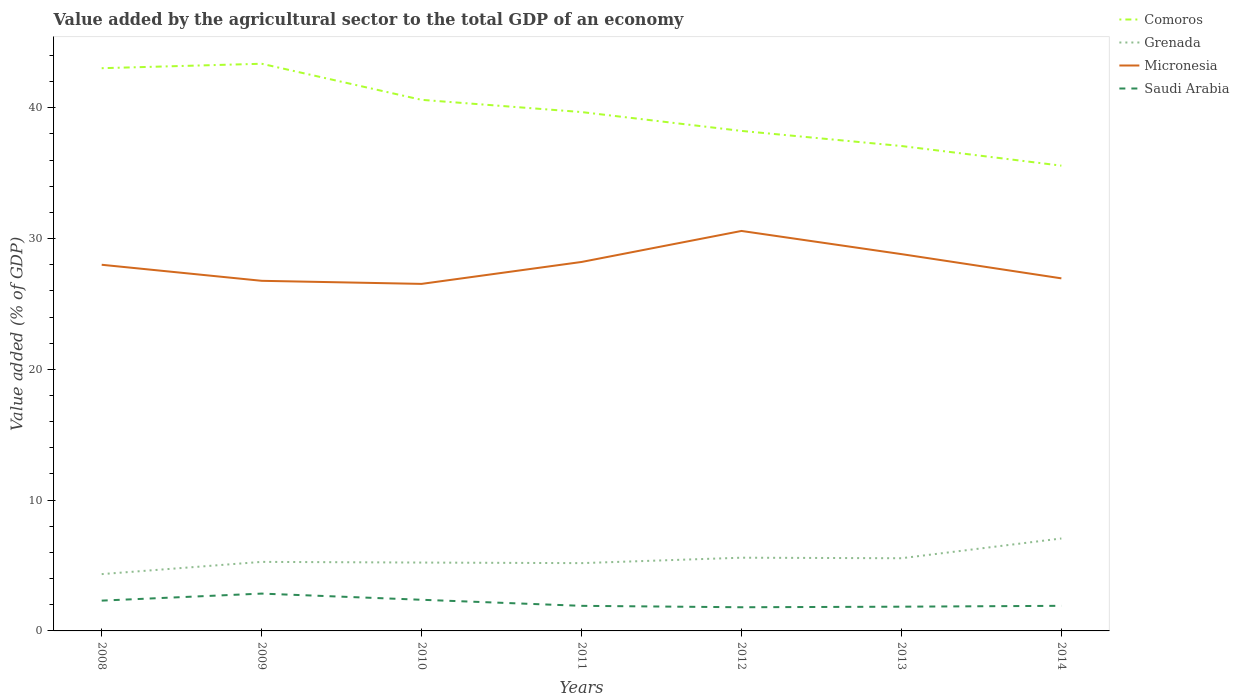How many different coloured lines are there?
Offer a very short reply. 4. Does the line corresponding to Micronesia intersect with the line corresponding to Comoros?
Provide a succinct answer. No. Is the number of lines equal to the number of legend labels?
Your answer should be very brief. Yes. Across all years, what is the maximum value added by the agricultural sector to the total GDP in Saudi Arabia?
Your answer should be very brief. 1.81. What is the total value added by the agricultural sector to the total GDP in Comoros in the graph?
Make the answer very short. 7.45. What is the difference between the highest and the second highest value added by the agricultural sector to the total GDP in Micronesia?
Provide a succinct answer. 4.05. What is the difference between the highest and the lowest value added by the agricultural sector to the total GDP in Comoros?
Your response must be concise. 4. Does the graph contain any zero values?
Give a very brief answer. No. Where does the legend appear in the graph?
Your response must be concise. Top right. How are the legend labels stacked?
Offer a terse response. Vertical. What is the title of the graph?
Provide a succinct answer. Value added by the agricultural sector to the total GDP of an economy. Does "Bermuda" appear as one of the legend labels in the graph?
Your answer should be very brief. No. What is the label or title of the X-axis?
Your answer should be very brief. Years. What is the label or title of the Y-axis?
Make the answer very short. Value added (% of GDP). What is the Value added (% of GDP) in Comoros in 2008?
Offer a very short reply. 43.03. What is the Value added (% of GDP) of Grenada in 2008?
Give a very brief answer. 4.34. What is the Value added (% of GDP) of Micronesia in 2008?
Offer a terse response. 28. What is the Value added (% of GDP) in Saudi Arabia in 2008?
Ensure brevity in your answer.  2.32. What is the Value added (% of GDP) in Comoros in 2009?
Provide a succinct answer. 43.37. What is the Value added (% of GDP) in Grenada in 2009?
Offer a terse response. 5.28. What is the Value added (% of GDP) in Micronesia in 2009?
Your answer should be very brief. 26.77. What is the Value added (% of GDP) of Saudi Arabia in 2009?
Provide a succinct answer. 2.85. What is the Value added (% of GDP) in Comoros in 2010?
Offer a very short reply. 40.61. What is the Value added (% of GDP) of Grenada in 2010?
Offer a terse response. 5.23. What is the Value added (% of GDP) in Micronesia in 2010?
Offer a very short reply. 26.54. What is the Value added (% of GDP) in Saudi Arabia in 2010?
Ensure brevity in your answer.  2.38. What is the Value added (% of GDP) in Comoros in 2011?
Offer a terse response. 39.68. What is the Value added (% of GDP) of Grenada in 2011?
Give a very brief answer. 5.18. What is the Value added (% of GDP) of Micronesia in 2011?
Keep it short and to the point. 28.21. What is the Value added (% of GDP) in Saudi Arabia in 2011?
Your answer should be very brief. 1.92. What is the Value added (% of GDP) of Comoros in 2012?
Your answer should be very brief. 38.23. What is the Value added (% of GDP) of Grenada in 2012?
Provide a short and direct response. 5.6. What is the Value added (% of GDP) in Micronesia in 2012?
Your answer should be very brief. 30.58. What is the Value added (% of GDP) of Saudi Arabia in 2012?
Your response must be concise. 1.81. What is the Value added (% of GDP) of Comoros in 2013?
Provide a short and direct response. 37.08. What is the Value added (% of GDP) in Grenada in 2013?
Your response must be concise. 5.56. What is the Value added (% of GDP) of Micronesia in 2013?
Offer a very short reply. 28.81. What is the Value added (% of GDP) in Saudi Arabia in 2013?
Your answer should be compact. 1.85. What is the Value added (% of GDP) of Comoros in 2014?
Provide a succinct answer. 35.58. What is the Value added (% of GDP) in Grenada in 2014?
Provide a short and direct response. 7.07. What is the Value added (% of GDP) of Micronesia in 2014?
Your answer should be very brief. 26.96. What is the Value added (% of GDP) of Saudi Arabia in 2014?
Give a very brief answer. 1.92. Across all years, what is the maximum Value added (% of GDP) of Comoros?
Your answer should be compact. 43.37. Across all years, what is the maximum Value added (% of GDP) of Grenada?
Your answer should be very brief. 7.07. Across all years, what is the maximum Value added (% of GDP) in Micronesia?
Ensure brevity in your answer.  30.58. Across all years, what is the maximum Value added (% of GDP) of Saudi Arabia?
Make the answer very short. 2.85. Across all years, what is the minimum Value added (% of GDP) in Comoros?
Keep it short and to the point. 35.58. Across all years, what is the minimum Value added (% of GDP) of Grenada?
Offer a terse response. 4.34. Across all years, what is the minimum Value added (% of GDP) in Micronesia?
Ensure brevity in your answer.  26.54. Across all years, what is the minimum Value added (% of GDP) of Saudi Arabia?
Provide a succinct answer. 1.81. What is the total Value added (% of GDP) in Comoros in the graph?
Your answer should be compact. 277.57. What is the total Value added (% of GDP) in Grenada in the graph?
Offer a terse response. 38.26. What is the total Value added (% of GDP) of Micronesia in the graph?
Provide a succinct answer. 195.88. What is the total Value added (% of GDP) in Saudi Arabia in the graph?
Give a very brief answer. 15.05. What is the difference between the Value added (% of GDP) in Comoros in 2008 and that in 2009?
Offer a very short reply. -0.34. What is the difference between the Value added (% of GDP) in Grenada in 2008 and that in 2009?
Your response must be concise. -0.94. What is the difference between the Value added (% of GDP) of Micronesia in 2008 and that in 2009?
Offer a very short reply. 1.23. What is the difference between the Value added (% of GDP) in Saudi Arabia in 2008 and that in 2009?
Provide a short and direct response. -0.54. What is the difference between the Value added (% of GDP) of Comoros in 2008 and that in 2010?
Provide a succinct answer. 2.42. What is the difference between the Value added (% of GDP) of Grenada in 2008 and that in 2010?
Ensure brevity in your answer.  -0.88. What is the difference between the Value added (% of GDP) in Micronesia in 2008 and that in 2010?
Offer a terse response. 1.46. What is the difference between the Value added (% of GDP) in Saudi Arabia in 2008 and that in 2010?
Your answer should be very brief. -0.07. What is the difference between the Value added (% of GDP) in Comoros in 2008 and that in 2011?
Make the answer very short. 3.35. What is the difference between the Value added (% of GDP) in Grenada in 2008 and that in 2011?
Make the answer very short. -0.84. What is the difference between the Value added (% of GDP) in Micronesia in 2008 and that in 2011?
Your response must be concise. -0.21. What is the difference between the Value added (% of GDP) in Saudi Arabia in 2008 and that in 2011?
Your response must be concise. 0.4. What is the difference between the Value added (% of GDP) in Comoros in 2008 and that in 2012?
Provide a short and direct response. 4.8. What is the difference between the Value added (% of GDP) of Grenada in 2008 and that in 2012?
Provide a succinct answer. -1.25. What is the difference between the Value added (% of GDP) in Micronesia in 2008 and that in 2012?
Your response must be concise. -2.59. What is the difference between the Value added (% of GDP) in Saudi Arabia in 2008 and that in 2012?
Your answer should be very brief. 0.51. What is the difference between the Value added (% of GDP) in Comoros in 2008 and that in 2013?
Give a very brief answer. 5.95. What is the difference between the Value added (% of GDP) in Grenada in 2008 and that in 2013?
Offer a terse response. -1.21. What is the difference between the Value added (% of GDP) in Micronesia in 2008 and that in 2013?
Give a very brief answer. -0.81. What is the difference between the Value added (% of GDP) in Saudi Arabia in 2008 and that in 2013?
Your answer should be very brief. 0.46. What is the difference between the Value added (% of GDP) of Comoros in 2008 and that in 2014?
Provide a short and direct response. 7.45. What is the difference between the Value added (% of GDP) in Grenada in 2008 and that in 2014?
Your response must be concise. -2.73. What is the difference between the Value added (% of GDP) of Micronesia in 2008 and that in 2014?
Provide a short and direct response. 1.04. What is the difference between the Value added (% of GDP) of Saudi Arabia in 2008 and that in 2014?
Your response must be concise. 0.4. What is the difference between the Value added (% of GDP) of Comoros in 2009 and that in 2010?
Keep it short and to the point. 2.76. What is the difference between the Value added (% of GDP) in Grenada in 2009 and that in 2010?
Make the answer very short. 0.05. What is the difference between the Value added (% of GDP) in Micronesia in 2009 and that in 2010?
Ensure brevity in your answer.  0.24. What is the difference between the Value added (% of GDP) of Saudi Arabia in 2009 and that in 2010?
Offer a very short reply. 0.47. What is the difference between the Value added (% of GDP) in Comoros in 2009 and that in 2011?
Provide a succinct answer. 3.69. What is the difference between the Value added (% of GDP) of Grenada in 2009 and that in 2011?
Offer a very short reply. 0.1. What is the difference between the Value added (% of GDP) of Micronesia in 2009 and that in 2011?
Provide a short and direct response. -1.44. What is the difference between the Value added (% of GDP) in Saudi Arabia in 2009 and that in 2011?
Ensure brevity in your answer.  0.94. What is the difference between the Value added (% of GDP) in Comoros in 2009 and that in 2012?
Provide a short and direct response. 5.14. What is the difference between the Value added (% of GDP) in Grenada in 2009 and that in 2012?
Offer a terse response. -0.32. What is the difference between the Value added (% of GDP) in Micronesia in 2009 and that in 2012?
Offer a very short reply. -3.81. What is the difference between the Value added (% of GDP) in Saudi Arabia in 2009 and that in 2012?
Offer a terse response. 1.04. What is the difference between the Value added (% of GDP) of Comoros in 2009 and that in 2013?
Offer a terse response. 6.29. What is the difference between the Value added (% of GDP) of Grenada in 2009 and that in 2013?
Offer a terse response. -0.28. What is the difference between the Value added (% of GDP) in Micronesia in 2009 and that in 2013?
Offer a very short reply. -2.04. What is the difference between the Value added (% of GDP) in Comoros in 2009 and that in 2014?
Ensure brevity in your answer.  7.79. What is the difference between the Value added (% of GDP) in Grenada in 2009 and that in 2014?
Your answer should be compact. -1.79. What is the difference between the Value added (% of GDP) of Micronesia in 2009 and that in 2014?
Your answer should be very brief. -0.19. What is the difference between the Value added (% of GDP) in Saudi Arabia in 2009 and that in 2014?
Your response must be concise. 0.93. What is the difference between the Value added (% of GDP) in Comoros in 2010 and that in 2011?
Your answer should be very brief. 0.93. What is the difference between the Value added (% of GDP) of Grenada in 2010 and that in 2011?
Keep it short and to the point. 0.04. What is the difference between the Value added (% of GDP) of Micronesia in 2010 and that in 2011?
Offer a very short reply. -1.68. What is the difference between the Value added (% of GDP) in Saudi Arabia in 2010 and that in 2011?
Ensure brevity in your answer.  0.46. What is the difference between the Value added (% of GDP) of Comoros in 2010 and that in 2012?
Ensure brevity in your answer.  2.38. What is the difference between the Value added (% of GDP) of Grenada in 2010 and that in 2012?
Make the answer very short. -0.37. What is the difference between the Value added (% of GDP) of Micronesia in 2010 and that in 2012?
Your answer should be very brief. -4.05. What is the difference between the Value added (% of GDP) in Saudi Arabia in 2010 and that in 2012?
Ensure brevity in your answer.  0.57. What is the difference between the Value added (% of GDP) of Comoros in 2010 and that in 2013?
Make the answer very short. 3.53. What is the difference between the Value added (% of GDP) of Grenada in 2010 and that in 2013?
Keep it short and to the point. -0.33. What is the difference between the Value added (% of GDP) in Micronesia in 2010 and that in 2013?
Your answer should be compact. -2.28. What is the difference between the Value added (% of GDP) of Saudi Arabia in 2010 and that in 2013?
Keep it short and to the point. 0.53. What is the difference between the Value added (% of GDP) of Comoros in 2010 and that in 2014?
Your answer should be compact. 5.03. What is the difference between the Value added (% of GDP) of Grenada in 2010 and that in 2014?
Ensure brevity in your answer.  -1.84. What is the difference between the Value added (% of GDP) in Micronesia in 2010 and that in 2014?
Your answer should be compact. -0.42. What is the difference between the Value added (% of GDP) in Saudi Arabia in 2010 and that in 2014?
Provide a succinct answer. 0.46. What is the difference between the Value added (% of GDP) of Comoros in 2011 and that in 2012?
Keep it short and to the point. 1.44. What is the difference between the Value added (% of GDP) in Grenada in 2011 and that in 2012?
Your answer should be compact. -0.42. What is the difference between the Value added (% of GDP) in Micronesia in 2011 and that in 2012?
Provide a short and direct response. -2.37. What is the difference between the Value added (% of GDP) in Saudi Arabia in 2011 and that in 2012?
Provide a succinct answer. 0.11. What is the difference between the Value added (% of GDP) in Comoros in 2011 and that in 2013?
Provide a succinct answer. 2.6. What is the difference between the Value added (% of GDP) in Grenada in 2011 and that in 2013?
Ensure brevity in your answer.  -0.37. What is the difference between the Value added (% of GDP) of Micronesia in 2011 and that in 2013?
Offer a terse response. -0.6. What is the difference between the Value added (% of GDP) of Saudi Arabia in 2011 and that in 2013?
Keep it short and to the point. 0.06. What is the difference between the Value added (% of GDP) of Comoros in 2011 and that in 2014?
Your answer should be very brief. 4.1. What is the difference between the Value added (% of GDP) of Grenada in 2011 and that in 2014?
Offer a terse response. -1.89. What is the difference between the Value added (% of GDP) in Micronesia in 2011 and that in 2014?
Provide a short and direct response. 1.25. What is the difference between the Value added (% of GDP) of Saudi Arabia in 2011 and that in 2014?
Your response must be concise. -0. What is the difference between the Value added (% of GDP) in Comoros in 2012 and that in 2013?
Provide a succinct answer. 1.15. What is the difference between the Value added (% of GDP) of Grenada in 2012 and that in 2013?
Offer a terse response. 0.04. What is the difference between the Value added (% of GDP) of Micronesia in 2012 and that in 2013?
Keep it short and to the point. 1.77. What is the difference between the Value added (% of GDP) of Saudi Arabia in 2012 and that in 2013?
Your answer should be compact. -0.04. What is the difference between the Value added (% of GDP) in Comoros in 2012 and that in 2014?
Provide a short and direct response. 2.66. What is the difference between the Value added (% of GDP) in Grenada in 2012 and that in 2014?
Provide a short and direct response. -1.47. What is the difference between the Value added (% of GDP) of Micronesia in 2012 and that in 2014?
Give a very brief answer. 3.62. What is the difference between the Value added (% of GDP) in Saudi Arabia in 2012 and that in 2014?
Your answer should be very brief. -0.11. What is the difference between the Value added (% of GDP) in Comoros in 2013 and that in 2014?
Your answer should be very brief. 1.5. What is the difference between the Value added (% of GDP) in Grenada in 2013 and that in 2014?
Your answer should be compact. -1.51. What is the difference between the Value added (% of GDP) in Micronesia in 2013 and that in 2014?
Keep it short and to the point. 1.85. What is the difference between the Value added (% of GDP) in Saudi Arabia in 2013 and that in 2014?
Offer a terse response. -0.07. What is the difference between the Value added (% of GDP) in Comoros in 2008 and the Value added (% of GDP) in Grenada in 2009?
Give a very brief answer. 37.75. What is the difference between the Value added (% of GDP) in Comoros in 2008 and the Value added (% of GDP) in Micronesia in 2009?
Keep it short and to the point. 16.26. What is the difference between the Value added (% of GDP) of Comoros in 2008 and the Value added (% of GDP) of Saudi Arabia in 2009?
Provide a short and direct response. 40.17. What is the difference between the Value added (% of GDP) in Grenada in 2008 and the Value added (% of GDP) in Micronesia in 2009?
Provide a short and direct response. -22.43. What is the difference between the Value added (% of GDP) of Grenada in 2008 and the Value added (% of GDP) of Saudi Arabia in 2009?
Ensure brevity in your answer.  1.49. What is the difference between the Value added (% of GDP) of Micronesia in 2008 and the Value added (% of GDP) of Saudi Arabia in 2009?
Your response must be concise. 25.14. What is the difference between the Value added (% of GDP) of Comoros in 2008 and the Value added (% of GDP) of Grenada in 2010?
Make the answer very short. 37.8. What is the difference between the Value added (% of GDP) of Comoros in 2008 and the Value added (% of GDP) of Micronesia in 2010?
Offer a terse response. 16.49. What is the difference between the Value added (% of GDP) of Comoros in 2008 and the Value added (% of GDP) of Saudi Arabia in 2010?
Make the answer very short. 40.65. What is the difference between the Value added (% of GDP) in Grenada in 2008 and the Value added (% of GDP) in Micronesia in 2010?
Your response must be concise. -22.19. What is the difference between the Value added (% of GDP) in Grenada in 2008 and the Value added (% of GDP) in Saudi Arabia in 2010?
Your response must be concise. 1.96. What is the difference between the Value added (% of GDP) of Micronesia in 2008 and the Value added (% of GDP) of Saudi Arabia in 2010?
Keep it short and to the point. 25.62. What is the difference between the Value added (% of GDP) of Comoros in 2008 and the Value added (% of GDP) of Grenada in 2011?
Keep it short and to the point. 37.85. What is the difference between the Value added (% of GDP) in Comoros in 2008 and the Value added (% of GDP) in Micronesia in 2011?
Provide a succinct answer. 14.82. What is the difference between the Value added (% of GDP) in Comoros in 2008 and the Value added (% of GDP) in Saudi Arabia in 2011?
Make the answer very short. 41.11. What is the difference between the Value added (% of GDP) of Grenada in 2008 and the Value added (% of GDP) of Micronesia in 2011?
Your answer should be very brief. -23.87. What is the difference between the Value added (% of GDP) in Grenada in 2008 and the Value added (% of GDP) in Saudi Arabia in 2011?
Offer a very short reply. 2.43. What is the difference between the Value added (% of GDP) in Micronesia in 2008 and the Value added (% of GDP) in Saudi Arabia in 2011?
Your answer should be compact. 26.08. What is the difference between the Value added (% of GDP) of Comoros in 2008 and the Value added (% of GDP) of Grenada in 2012?
Give a very brief answer. 37.43. What is the difference between the Value added (% of GDP) in Comoros in 2008 and the Value added (% of GDP) in Micronesia in 2012?
Provide a short and direct response. 12.44. What is the difference between the Value added (% of GDP) in Comoros in 2008 and the Value added (% of GDP) in Saudi Arabia in 2012?
Keep it short and to the point. 41.22. What is the difference between the Value added (% of GDP) in Grenada in 2008 and the Value added (% of GDP) in Micronesia in 2012?
Offer a terse response. -26.24. What is the difference between the Value added (% of GDP) of Grenada in 2008 and the Value added (% of GDP) of Saudi Arabia in 2012?
Your answer should be very brief. 2.53. What is the difference between the Value added (% of GDP) of Micronesia in 2008 and the Value added (% of GDP) of Saudi Arabia in 2012?
Make the answer very short. 26.19. What is the difference between the Value added (% of GDP) in Comoros in 2008 and the Value added (% of GDP) in Grenada in 2013?
Your answer should be compact. 37.47. What is the difference between the Value added (% of GDP) in Comoros in 2008 and the Value added (% of GDP) in Micronesia in 2013?
Your response must be concise. 14.22. What is the difference between the Value added (% of GDP) of Comoros in 2008 and the Value added (% of GDP) of Saudi Arabia in 2013?
Your answer should be compact. 41.18. What is the difference between the Value added (% of GDP) of Grenada in 2008 and the Value added (% of GDP) of Micronesia in 2013?
Give a very brief answer. -24.47. What is the difference between the Value added (% of GDP) in Grenada in 2008 and the Value added (% of GDP) in Saudi Arabia in 2013?
Give a very brief answer. 2.49. What is the difference between the Value added (% of GDP) in Micronesia in 2008 and the Value added (% of GDP) in Saudi Arabia in 2013?
Give a very brief answer. 26.14. What is the difference between the Value added (% of GDP) in Comoros in 2008 and the Value added (% of GDP) in Grenada in 2014?
Ensure brevity in your answer.  35.96. What is the difference between the Value added (% of GDP) in Comoros in 2008 and the Value added (% of GDP) in Micronesia in 2014?
Your response must be concise. 16.07. What is the difference between the Value added (% of GDP) of Comoros in 2008 and the Value added (% of GDP) of Saudi Arabia in 2014?
Your answer should be very brief. 41.11. What is the difference between the Value added (% of GDP) in Grenada in 2008 and the Value added (% of GDP) in Micronesia in 2014?
Your answer should be very brief. -22.62. What is the difference between the Value added (% of GDP) of Grenada in 2008 and the Value added (% of GDP) of Saudi Arabia in 2014?
Provide a succinct answer. 2.42. What is the difference between the Value added (% of GDP) of Micronesia in 2008 and the Value added (% of GDP) of Saudi Arabia in 2014?
Offer a very short reply. 26.08. What is the difference between the Value added (% of GDP) of Comoros in 2009 and the Value added (% of GDP) of Grenada in 2010?
Provide a succinct answer. 38.14. What is the difference between the Value added (% of GDP) in Comoros in 2009 and the Value added (% of GDP) in Micronesia in 2010?
Your answer should be very brief. 16.83. What is the difference between the Value added (% of GDP) in Comoros in 2009 and the Value added (% of GDP) in Saudi Arabia in 2010?
Your response must be concise. 40.99. What is the difference between the Value added (% of GDP) of Grenada in 2009 and the Value added (% of GDP) of Micronesia in 2010?
Ensure brevity in your answer.  -21.26. What is the difference between the Value added (% of GDP) of Grenada in 2009 and the Value added (% of GDP) of Saudi Arabia in 2010?
Your answer should be compact. 2.9. What is the difference between the Value added (% of GDP) in Micronesia in 2009 and the Value added (% of GDP) in Saudi Arabia in 2010?
Offer a very short reply. 24.39. What is the difference between the Value added (% of GDP) in Comoros in 2009 and the Value added (% of GDP) in Grenada in 2011?
Give a very brief answer. 38.19. What is the difference between the Value added (% of GDP) of Comoros in 2009 and the Value added (% of GDP) of Micronesia in 2011?
Offer a very short reply. 15.16. What is the difference between the Value added (% of GDP) in Comoros in 2009 and the Value added (% of GDP) in Saudi Arabia in 2011?
Give a very brief answer. 41.45. What is the difference between the Value added (% of GDP) of Grenada in 2009 and the Value added (% of GDP) of Micronesia in 2011?
Give a very brief answer. -22.93. What is the difference between the Value added (% of GDP) of Grenada in 2009 and the Value added (% of GDP) of Saudi Arabia in 2011?
Provide a short and direct response. 3.36. What is the difference between the Value added (% of GDP) in Micronesia in 2009 and the Value added (% of GDP) in Saudi Arabia in 2011?
Ensure brevity in your answer.  24.85. What is the difference between the Value added (% of GDP) in Comoros in 2009 and the Value added (% of GDP) in Grenada in 2012?
Your answer should be very brief. 37.77. What is the difference between the Value added (% of GDP) of Comoros in 2009 and the Value added (% of GDP) of Micronesia in 2012?
Your answer should be compact. 12.78. What is the difference between the Value added (% of GDP) in Comoros in 2009 and the Value added (% of GDP) in Saudi Arabia in 2012?
Your answer should be compact. 41.56. What is the difference between the Value added (% of GDP) in Grenada in 2009 and the Value added (% of GDP) in Micronesia in 2012?
Offer a terse response. -25.31. What is the difference between the Value added (% of GDP) of Grenada in 2009 and the Value added (% of GDP) of Saudi Arabia in 2012?
Make the answer very short. 3.47. What is the difference between the Value added (% of GDP) of Micronesia in 2009 and the Value added (% of GDP) of Saudi Arabia in 2012?
Provide a succinct answer. 24.96. What is the difference between the Value added (% of GDP) in Comoros in 2009 and the Value added (% of GDP) in Grenada in 2013?
Keep it short and to the point. 37.81. What is the difference between the Value added (% of GDP) of Comoros in 2009 and the Value added (% of GDP) of Micronesia in 2013?
Your answer should be very brief. 14.56. What is the difference between the Value added (% of GDP) of Comoros in 2009 and the Value added (% of GDP) of Saudi Arabia in 2013?
Your answer should be very brief. 41.52. What is the difference between the Value added (% of GDP) in Grenada in 2009 and the Value added (% of GDP) in Micronesia in 2013?
Ensure brevity in your answer.  -23.53. What is the difference between the Value added (% of GDP) of Grenada in 2009 and the Value added (% of GDP) of Saudi Arabia in 2013?
Provide a short and direct response. 3.43. What is the difference between the Value added (% of GDP) in Micronesia in 2009 and the Value added (% of GDP) in Saudi Arabia in 2013?
Provide a short and direct response. 24.92. What is the difference between the Value added (% of GDP) of Comoros in 2009 and the Value added (% of GDP) of Grenada in 2014?
Your answer should be very brief. 36.3. What is the difference between the Value added (% of GDP) of Comoros in 2009 and the Value added (% of GDP) of Micronesia in 2014?
Provide a succinct answer. 16.41. What is the difference between the Value added (% of GDP) in Comoros in 2009 and the Value added (% of GDP) in Saudi Arabia in 2014?
Provide a short and direct response. 41.45. What is the difference between the Value added (% of GDP) of Grenada in 2009 and the Value added (% of GDP) of Micronesia in 2014?
Your answer should be compact. -21.68. What is the difference between the Value added (% of GDP) of Grenada in 2009 and the Value added (% of GDP) of Saudi Arabia in 2014?
Your answer should be very brief. 3.36. What is the difference between the Value added (% of GDP) in Micronesia in 2009 and the Value added (% of GDP) in Saudi Arabia in 2014?
Make the answer very short. 24.85. What is the difference between the Value added (% of GDP) of Comoros in 2010 and the Value added (% of GDP) of Grenada in 2011?
Offer a very short reply. 35.43. What is the difference between the Value added (% of GDP) in Comoros in 2010 and the Value added (% of GDP) in Micronesia in 2011?
Provide a short and direct response. 12.4. What is the difference between the Value added (% of GDP) of Comoros in 2010 and the Value added (% of GDP) of Saudi Arabia in 2011?
Give a very brief answer. 38.69. What is the difference between the Value added (% of GDP) in Grenada in 2010 and the Value added (% of GDP) in Micronesia in 2011?
Provide a succinct answer. -22.98. What is the difference between the Value added (% of GDP) of Grenada in 2010 and the Value added (% of GDP) of Saudi Arabia in 2011?
Your response must be concise. 3.31. What is the difference between the Value added (% of GDP) of Micronesia in 2010 and the Value added (% of GDP) of Saudi Arabia in 2011?
Your answer should be compact. 24.62. What is the difference between the Value added (% of GDP) of Comoros in 2010 and the Value added (% of GDP) of Grenada in 2012?
Your answer should be compact. 35.01. What is the difference between the Value added (% of GDP) in Comoros in 2010 and the Value added (% of GDP) in Micronesia in 2012?
Offer a terse response. 10.03. What is the difference between the Value added (% of GDP) of Comoros in 2010 and the Value added (% of GDP) of Saudi Arabia in 2012?
Offer a very short reply. 38.8. What is the difference between the Value added (% of GDP) in Grenada in 2010 and the Value added (% of GDP) in Micronesia in 2012?
Offer a terse response. -25.36. What is the difference between the Value added (% of GDP) of Grenada in 2010 and the Value added (% of GDP) of Saudi Arabia in 2012?
Provide a succinct answer. 3.42. What is the difference between the Value added (% of GDP) in Micronesia in 2010 and the Value added (% of GDP) in Saudi Arabia in 2012?
Provide a succinct answer. 24.73. What is the difference between the Value added (% of GDP) of Comoros in 2010 and the Value added (% of GDP) of Grenada in 2013?
Make the answer very short. 35.05. What is the difference between the Value added (% of GDP) of Comoros in 2010 and the Value added (% of GDP) of Micronesia in 2013?
Give a very brief answer. 11.8. What is the difference between the Value added (% of GDP) in Comoros in 2010 and the Value added (% of GDP) in Saudi Arabia in 2013?
Keep it short and to the point. 38.76. What is the difference between the Value added (% of GDP) of Grenada in 2010 and the Value added (% of GDP) of Micronesia in 2013?
Your answer should be very brief. -23.59. What is the difference between the Value added (% of GDP) of Grenada in 2010 and the Value added (% of GDP) of Saudi Arabia in 2013?
Your answer should be very brief. 3.37. What is the difference between the Value added (% of GDP) in Micronesia in 2010 and the Value added (% of GDP) in Saudi Arabia in 2013?
Your answer should be compact. 24.68. What is the difference between the Value added (% of GDP) in Comoros in 2010 and the Value added (% of GDP) in Grenada in 2014?
Your answer should be very brief. 33.54. What is the difference between the Value added (% of GDP) in Comoros in 2010 and the Value added (% of GDP) in Micronesia in 2014?
Keep it short and to the point. 13.65. What is the difference between the Value added (% of GDP) in Comoros in 2010 and the Value added (% of GDP) in Saudi Arabia in 2014?
Make the answer very short. 38.69. What is the difference between the Value added (% of GDP) of Grenada in 2010 and the Value added (% of GDP) of Micronesia in 2014?
Provide a short and direct response. -21.73. What is the difference between the Value added (% of GDP) in Grenada in 2010 and the Value added (% of GDP) in Saudi Arabia in 2014?
Give a very brief answer. 3.31. What is the difference between the Value added (% of GDP) of Micronesia in 2010 and the Value added (% of GDP) of Saudi Arabia in 2014?
Provide a short and direct response. 24.62. What is the difference between the Value added (% of GDP) of Comoros in 2011 and the Value added (% of GDP) of Grenada in 2012?
Provide a succinct answer. 34.08. What is the difference between the Value added (% of GDP) of Comoros in 2011 and the Value added (% of GDP) of Micronesia in 2012?
Keep it short and to the point. 9.09. What is the difference between the Value added (% of GDP) of Comoros in 2011 and the Value added (% of GDP) of Saudi Arabia in 2012?
Your answer should be very brief. 37.87. What is the difference between the Value added (% of GDP) in Grenada in 2011 and the Value added (% of GDP) in Micronesia in 2012?
Offer a very short reply. -25.4. What is the difference between the Value added (% of GDP) of Grenada in 2011 and the Value added (% of GDP) of Saudi Arabia in 2012?
Provide a succinct answer. 3.37. What is the difference between the Value added (% of GDP) in Micronesia in 2011 and the Value added (% of GDP) in Saudi Arabia in 2012?
Your response must be concise. 26.4. What is the difference between the Value added (% of GDP) of Comoros in 2011 and the Value added (% of GDP) of Grenada in 2013?
Make the answer very short. 34.12. What is the difference between the Value added (% of GDP) of Comoros in 2011 and the Value added (% of GDP) of Micronesia in 2013?
Offer a very short reply. 10.86. What is the difference between the Value added (% of GDP) of Comoros in 2011 and the Value added (% of GDP) of Saudi Arabia in 2013?
Give a very brief answer. 37.82. What is the difference between the Value added (% of GDP) of Grenada in 2011 and the Value added (% of GDP) of Micronesia in 2013?
Provide a short and direct response. -23.63. What is the difference between the Value added (% of GDP) of Grenada in 2011 and the Value added (% of GDP) of Saudi Arabia in 2013?
Make the answer very short. 3.33. What is the difference between the Value added (% of GDP) of Micronesia in 2011 and the Value added (% of GDP) of Saudi Arabia in 2013?
Provide a short and direct response. 26.36. What is the difference between the Value added (% of GDP) of Comoros in 2011 and the Value added (% of GDP) of Grenada in 2014?
Provide a short and direct response. 32.61. What is the difference between the Value added (% of GDP) of Comoros in 2011 and the Value added (% of GDP) of Micronesia in 2014?
Offer a terse response. 12.72. What is the difference between the Value added (% of GDP) in Comoros in 2011 and the Value added (% of GDP) in Saudi Arabia in 2014?
Your answer should be compact. 37.76. What is the difference between the Value added (% of GDP) of Grenada in 2011 and the Value added (% of GDP) of Micronesia in 2014?
Provide a succinct answer. -21.78. What is the difference between the Value added (% of GDP) of Grenada in 2011 and the Value added (% of GDP) of Saudi Arabia in 2014?
Provide a succinct answer. 3.26. What is the difference between the Value added (% of GDP) in Micronesia in 2011 and the Value added (% of GDP) in Saudi Arabia in 2014?
Keep it short and to the point. 26.29. What is the difference between the Value added (% of GDP) in Comoros in 2012 and the Value added (% of GDP) in Grenada in 2013?
Offer a terse response. 32.68. What is the difference between the Value added (% of GDP) in Comoros in 2012 and the Value added (% of GDP) in Micronesia in 2013?
Offer a very short reply. 9.42. What is the difference between the Value added (% of GDP) in Comoros in 2012 and the Value added (% of GDP) in Saudi Arabia in 2013?
Ensure brevity in your answer.  36.38. What is the difference between the Value added (% of GDP) in Grenada in 2012 and the Value added (% of GDP) in Micronesia in 2013?
Provide a short and direct response. -23.21. What is the difference between the Value added (% of GDP) in Grenada in 2012 and the Value added (% of GDP) in Saudi Arabia in 2013?
Provide a short and direct response. 3.75. What is the difference between the Value added (% of GDP) of Micronesia in 2012 and the Value added (% of GDP) of Saudi Arabia in 2013?
Ensure brevity in your answer.  28.73. What is the difference between the Value added (% of GDP) in Comoros in 2012 and the Value added (% of GDP) in Grenada in 2014?
Provide a short and direct response. 31.16. What is the difference between the Value added (% of GDP) of Comoros in 2012 and the Value added (% of GDP) of Micronesia in 2014?
Your response must be concise. 11.27. What is the difference between the Value added (% of GDP) in Comoros in 2012 and the Value added (% of GDP) in Saudi Arabia in 2014?
Your response must be concise. 36.31. What is the difference between the Value added (% of GDP) in Grenada in 2012 and the Value added (% of GDP) in Micronesia in 2014?
Offer a very short reply. -21.36. What is the difference between the Value added (% of GDP) of Grenada in 2012 and the Value added (% of GDP) of Saudi Arabia in 2014?
Offer a terse response. 3.68. What is the difference between the Value added (% of GDP) in Micronesia in 2012 and the Value added (% of GDP) in Saudi Arabia in 2014?
Provide a short and direct response. 28.66. What is the difference between the Value added (% of GDP) of Comoros in 2013 and the Value added (% of GDP) of Grenada in 2014?
Ensure brevity in your answer.  30.01. What is the difference between the Value added (% of GDP) of Comoros in 2013 and the Value added (% of GDP) of Micronesia in 2014?
Give a very brief answer. 10.12. What is the difference between the Value added (% of GDP) in Comoros in 2013 and the Value added (% of GDP) in Saudi Arabia in 2014?
Your response must be concise. 35.16. What is the difference between the Value added (% of GDP) in Grenada in 2013 and the Value added (% of GDP) in Micronesia in 2014?
Make the answer very short. -21.4. What is the difference between the Value added (% of GDP) in Grenada in 2013 and the Value added (% of GDP) in Saudi Arabia in 2014?
Your response must be concise. 3.64. What is the difference between the Value added (% of GDP) in Micronesia in 2013 and the Value added (% of GDP) in Saudi Arabia in 2014?
Give a very brief answer. 26.89. What is the average Value added (% of GDP) of Comoros per year?
Give a very brief answer. 39.65. What is the average Value added (% of GDP) of Grenada per year?
Keep it short and to the point. 5.47. What is the average Value added (% of GDP) in Micronesia per year?
Make the answer very short. 27.98. What is the average Value added (% of GDP) of Saudi Arabia per year?
Your answer should be very brief. 2.15. In the year 2008, what is the difference between the Value added (% of GDP) in Comoros and Value added (% of GDP) in Grenada?
Offer a very short reply. 38.69. In the year 2008, what is the difference between the Value added (% of GDP) in Comoros and Value added (% of GDP) in Micronesia?
Offer a terse response. 15.03. In the year 2008, what is the difference between the Value added (% of GDP) in Comoros and Value added (% of GDP) in Saudi Arabia?
Keep it short and to the point. 40.71. In the year 2008, what is the difference between the Value added (% of GDP) of Grenada and Value added (% of GDP) of Micronesia?
Provide a succinct answer. -23.65. In the year 2008, what is the difference between the Value added (% of GDP) in Grenada and Value added (% of GDP) in Saudi Arabia?
Provide a succinct answer. 2.03. In the year 2008, what is the difference between the Value added (% of GDP) of Micronesia and Value added (% of GDP) of Saudi Arabia?
Your answer should be compact. 25.68. In the year 2009, what is the difference between the Value added (% of GDP) in Comoros and Value added (% of GDP) in Grenada?
Give a very brief answer. 38.09. In the year 2009, what is the difference between the Value added (% of GDP) of Comoros and Value added (% of GDP) of Micronesia?
Provide a short and direct response. 16.6. In the year 2009, what is the difference between the Value added (% of GDP) of Comoros and Value added (% of GDP) of Saudi Arabia?
Give a very brief answer. 40.52. In the year 2009, what is the difference between the Value added (% of GDP) in Grenada and Value added (% of GDP) in Micronesia?
Provide a succinct answer. -21.49. In the year 2009, what is the difference between the Value added (% of GDP) in Grenada and Value added (% of GDP) in Saudi Arabia?
Make the answer very short. 2.43. In the year 2009, what is the difference between the Value added (% of GDP) of Micronesia and Value added (% of GDP) of Saudi Arabia?
Offer a very short reply. 23.92. In the year 2010, what is the difference between the Value added (% of GDP) of Comoros and Value added (% of GDP) of Grenada?
Provide a succinct answer. 35.38. In the year 2010, what is the difference between the Value added (% of GDP) in Comoros and Value added (% of GDP) in Micronesia?
Your answer should be very brief. 14.07. In the year 2010, what is the difference between the Value added (% of GDP) of Comoros and Value added (% of GDP) of Saudi Arabia?
Ensure brevity in your answer.  38.23. In the year 2010, what is the difference between the Value added (% of GDP) of Grenada and Value added (% of GDP) of Micronesia?
Ensure brevity in your answer.  -21.31. In the year 2010, what is the difference between the Value added (% of GDP) in Grenada and Value added (% of GDP) in Saudi Arabia?
Your response must be concise. 2.85. In the year 2010, what is the difference between the Value added (% of GDP) of Micronesia and Value added (% of GDP) of Saudi Arabia?
Give a very brief answer. 24.15. In the year 2011, what is the difference between the Value added (% of GDP) in Comoros and Value added (% of GDP) in Grenada?
Provide a short and direct response. 34.49. In the year 2011, what is the difference between the Value added (% of GDP) of Comoros and Value added (% of GDP) of Micronesia?
Offer a very short reply. 11.46. In the year 2011, what is the difference between the Value added (% of GDP) of Comoros and Value added (% of GDP) of Saudi Arabia?
Provide a short and direct response. 37.76. In the year 2011, what is the difference between the Value added (% of GDP) of Grenada and Value added (% of GDP) of Micronesia?
Keep it short and to the point. -23.03. In the year 2011, what is the difference between the Value added (% of GDP) of Grenada and Value added (% of GDP) of Saudi Arabia?
Offer a very short reply. 3.27. In the year 2011, what is the difference between the Value added (% of GDP) in Micronesia and Value added (% of GDP) in Saudi Arabia?
Ensure brevity in your answer.  26.29. In the year 2012, what is the difference between the Value added (% of GDP) of Comoros and Value added (% of GDP) of Grenada?
Give a very brief answer. 32.63. In the year 2012, what is the difference between the Value added (% of GDP) of Comoros and Value added (% of GDP) of Micronesia?
Offer a terse response. 7.65. In the year 2012, what is the difference between the Value added (% of GDP) of Comoros and Value added (% of GDP) of Saudi Arabia?
Your answer should be very brief. 36.42. In the year 2012, what is the difference between the Value added (% of GDP) of Grenada and Value added (% of GDP) of Micronesia?
Your answer should be very brief. -24.99. In the year 2012, what is the difference between the Value added (% of GDP) of Grenada and Value added (% of GDP) of Saudi Arabia?
Offer a very short reply. 3.79. In the year 2012, what is the difference between the Value added (% of GDP) in Micronesia and Value added (% of GDP) in Saudi Arabia?
Offer a terse response. 28.77. In the year 2013, what is the difference between the Value added (% of GDP) of Comoros and Value added (% of GDP) of Grenada?
Your answer should be very brief. 31.52. In the year 2013, what is the difference between the Value added (% of GDP) in Comoros and Value added (% of GDP) in Micronesia?
Ensure brevity in your answer.  8.27. In the year 2013, what is the difference between the Value added (% of GDP) of Comoros and Value added (% of GDP) of Saudi Arabia?
Offer a very short reply. 35.23. In the year 2013, what is the difference between the Value added (% of GDP) in Grenada and Value added (% of GDP) in Micronesia?
Offer a very short reply. -23.26. In the year 2013, what is the difference between the Value added (% of GDP) of Grenada and Value added (% of GDP) of Saudi Arabia?
Your answer should be very brief. 3.7. In the year 2013, what is the difference between the Value added (% of GDP) in Micronesia and Value added (% of GDP) in Saudi Arabia?
Your answer should be very brief. 26.96. In the year 2014, what is the difference between the Value added (% of GDP) of Comoros and Value added (% of GDP) of Grenada?
Provide a short and direct response. 28.51. In the year 2014, what is the difference between the Value added (% of GDP) of Comoros and Value added (% of GDP) of Micronesia?
Give a very brief answer. 8.62. In the year 2014, what is the difference between the Value added (% of GDP) in Comoros and Value added (% of GDP) in Saudi Arabia?
Keep it short and to the point. 33.66. In the year 2014, what is the difference between the Value added (% of GDP) in Grenada and Value added (% of GDP) in Micronesia?
Your answer should be very brief. -19.89. In the year 2014, what is the difference between the Value added (% of GDP) in Grenada and Value added (% of GDP) in Saudi Arabia?
Your response must be concise. 5.15. In the year 2014, what is the difference between the Value added (% of GDP) in Micronesia and Value added (% of GDP) in Saudi Arabia?
Offer a very short reply. 25.04. What is the ratio of the Value added (% of GDP) of Grenada in 2008 to that in 2009?
Keep it short and to the point. 0.82. What is the ratio of the Value added (% of GDP) of Micronesia in 2008 to that in 2009?
Make the answer very short. 1.05. What is the ratio of the Value added (% of GDP) in Saudi Arabia in 2008 to that in 2009?
Give a very brief answer. 0.81. What is the ratio of the Value added (% of GDP) of Comoros in 2008 to that in 2010?
Provide a short and direct response. 1.06. What is the ratio of the Value added (% of GDP) in Grenada in 2008 to that in 2010?
Offer a terse response. 0.83. What is the ratio of the Value added (% of GDP) in Micronesia in 2008 to that in 2010?
Keep it short and to the point. 1.06. What is the ratio of the Value added (% of GDP) in Saudi Arabia in 2008 to that in 2010?
Your response must be concise. 0.97. What is the ratio of the Value added (% of GDP) of Comoros in 2008 to that in 2011?
Your answer should be compact. 1.08. What is the ratio of the Value added (% of GDP) of Grenada in 2008 to that in 2011?
Your answer should be very brief. 0.84. What is the ratio of the Value added (% of GDP) in Saudi Arabia in 2008 to that in 2011?
Provide a succinct answer. 1.21. What is the ratio of the Value added (% of GDP) in Comoros in 2008 to that in 2012?
Your answer should be very brief. 1.13. What is the ratio of the Value added (% of GDP) of Grenada in 2008 to that in 2012?
Make the answer very short. 0.78. What is the ratio of the Value added (% of GDP) in Micronesia in 2008 to that in 2012?
Your response must be concise. 0.92. What is the ratio of the Value added (% of GDP) of Saudi Arabia in 2008 to that in 2012?
Provide a succinct answer. 1.28. What is the ratio of the Value added (% of GDP) in Comoros in 2008 to that in 2013?
Keep it short and to the point. 1.16. What is the ratio of the Value added (% of GDP) in Grenada in 2008 to that in 2013?
Your answer should be compact. 0.78. What is the ratio of the Value added (% of GDP) in Micronesia in 2008 to that in 2013?
Offer a terse response. 0.97. What is the ratio of the Value added (% of GDP) of Comoros in 2008 to that in 2014?
Give a very brief answer. 1.21. What is the ratio of the Value added (% of GDP) of Grenada in 2008 to that in 2014?
Offer a very short reply. 0.61. What is the ratio of the Value added (% of GDP) of Saudi Arabia in 2008 to that in 2014?
Ensure brevity in your answer.  1.21. What is the ratio of the Value added (% of GDP) in Comoros in 2009 to that in 2010?
Provide a short and direct response. 1.07. What is the ratio of the Value added (% of GDP) of Grenada in 2009 to that in 2010?
Provide a succinct answer. 1.01. What is the ratio of the Value added (% of GDP) of Micronesia in 2009 to that in 2010?
Give a very brief answer. 1.01. What is the ratio of the Value added (% of GDP) in Saudi Arabia in 2009 to that in 2010?
Keep it short and to the point. 1.2. What is the ratio of the Value added (% of GDP) of Comoros in 2009 to that in 2011?
Offer a very short reply. 1.09. What is the ratio of the Value added (% of GDP) in Grenada in 2009 to that in 2011?
Your response must be concise. 1.02. What is the ratio of the Value added (% of GDP) of Micronesia in 2009 to that in 2011?
Your answer should be very brief. 0.95. What is the ratio of the Value added (% of GDP) in Saudi Arabia in 2009 to that in 2011?
Ensure brevity in your answer.  1.49. What is the ratio of the Value added (% of GDP) of Comoros in 2009 to that in 2012?
Your response must be concise. 1.13. What is the ratio of the Value added (% of GDP) of Grenada in 2009 to that in 2012?
Make the answer very short. 0.94. What is the ratio of the Value added (% of GDP) of Micronesia in 2009 to that in 2012?
Offer a terse response. 0.88. What is the ratio of the Value added (% of GDP) of Saudi Arabia in 2009 to that in 2012?
Provide a succinct answer. 1.58. What is the ratio of the Value added (% of GDP) in Comoros in 2009 to that in 2013?
Your answer should be compact. 1.17. What is the ratio of the Value added (% of GDP) in Grenada in 2009 to that in 2013?
Make the answer very short. 0.95. What is the ratio of the Value added (% of GDP) in Micronesia in 2009 to that in 2013?
Provide a succinct answer. 0.93. What is the ratio of the Value added (% of GDP) in Saudi Arabia in 2009 to that in 2013?
Make the answer very short. 1.54. What is the ratio of the Value added (% of GDP) in Comoros in 2009 to that in 2014?
Offer a terse response. 1.22. What is the ratio of the Value added (% of GDP) in Grenada in 2009 to that in 2014?
Ensure brevity in your answer.  0.75. What is the ratio of the Value added (% of GDP) of Saudi Arabia in 2009 to that in 2014?
Your answer should be very brief. 1.49. What is the ratio of the Value added (% of GDP) in Comoros in 2010 to that in 2011?
Offer a terse response. 1.02. What is the ratio of the Value added (% of GDP) in Grenada in 2010 to that in 2011?
Make the answer very short. 1.01. What is the ratio of the Value added (% of GDP) in Micronesia in 2010 to that in 2011?
Keep it short and to the point. 0.94. What is the ratio of the Value added (% of GDP) of Saudi Arabia in 2010 to that in 2011?
Provide a succinct answer. 1.24. What is the ratio of the Value added (% of GDP) of Comoros in 2010 to that in 2012?
Provide a short and direct response. 1.06. What is the ratio of the Value added (% of GDP) of Grenada in 2010 to that in 2012?
Offer a very short reply. 0.93. What is the ratio of the Value added (% of GDP) of Micronesia in 2010 to that in 2012?
Offer a terse response. 0.87. What is the ratio of the Value added (% of GDP) in Saudi Arabia in 2010 to that in 2012?
Ensure brevity in your answer.  1.32. What is the ratio of the Value added (% of GDP) in Comoros in 2010 to that in 2013?
Ensure brevity in your answer.  1.1. What is the ratio of the Value added (% of GDP) of Grenada in 2010 to that in 2013?
Offer a terse response. 0.94. What is the ratio of the Value added (% of GDP) of Micronesia in 2010 to that in 2013?
Your answer should be very brief. 0.92. What is the ratio of the Value added (% of GDP) in Saudi Arabia in 2010 to that in 2013?
Offer a terse response. 1.29. What is the ratio of the Value added (% of GDP) in Comoros in 2010 to that in 2014?
Offer a very short reply. 1.14. What is the ratio of the Value added (% of GDP) in Grenada in 2010 to that in 2014?
Ensure brevity in your answer.  0.74. What is the ratio of the Value added (% of GDP) in Micronesia in 2010 to that in 2014?
Your answer should be compact. 0.98. What is the ratio of the Value added (% of GDP) of Saudi Arabia in 2010 to that in 2014?
Give a very brief answer. 1.24. What is the ratio of the Value added (% of GDP) of Comoros in 2011 to that in 2012?
Provide a succinct answer. 1.04. What is the ratio of the Value added (% of GDP) in Grenada in 2011 to that in 2012?
Your answer should be compact. 0.93. What is the ratio of the Value added (% of GDP) of Micronesia in 2011 to that in 2012?
Offer a very short reply. 0.92. What is the ratio of the Value added (% of GDP) in Saudi Arabia in 2011 to that in 2012?
Your answer should be very brief. 1.06. What is the ratio of the Value added (% of GDP) of Comoros in 2011 to that in 2013?
Offer a terse response. 1.07. What is the ratio of the Value added (% of GDP) of Grenada in 2011 to that in 2013?
Your answer should be compact. 0.93. What is the ratio of the Value added (% of GDP) of Micronesia in 2011 to that in 2013?
Give a very brief answer. 0.98. What is the ratio of the Value added (% of GDP) in Saudi Arabia in 2011 to that in 2013?
Your response must be concise. 1.03. What is the ratio of the Value added (% of GDP) of Comoros in 2011 to that in 2014?
Your answer should be very brief. 1.12. What is the ratio of the Value added (% of GDP) of Grenada in 2011 to that in 2014?
Provide a succinct answer. 0.73. What is the ratio of the Value added (% of GDP) of Micronesia in 2011 to that in 2014?
Your answer should be very brief. 1.05. What is the ratio of the Value added (% of GDP) of Saudi Arabia in 2011 to that in 2014?
Your answer should be compact. 1. What is the ratio of the Value added (% of GDP) in Comoros in 2012 to that in 2013?
Your response must be concise. 1.03. What is the ratio of the Value added (% of GDP) of Grenada in 2012 to that in 2013?
Your answer should be compact. 1.01. What is the ratio of the Value added (% of GDP) of Micronesia in 2012 to that in 2013?
Keep it short and to the point. 1.06. What is the ratio of the Value added (% of GDP) in Saudi Arabia in 2012 to that in 2013?
Ensure brevity in your answer.  0.98. What is the ratio of the Value added (% of GDP) of Comoros in 2012 to that in 2014?
Offer a very short reply. 1.07. What is the ratio of the Value added (% of GDP) in Grenada in 2012 to that in 2014?
Keep it short and to the point. 0.79. What is the ratio of the Value added (% of GDP) of Micronesia in 2012 to that in 2014?
Your response must be concise. 1.13. What is the ratio of the Value added (% of GDP) in Saudi Arabia in 2012 to that in 2014?
Provide a succinct answer. 0.94. What is the ratio of the Value added (% of GDP) in Comoros in 2013 to that in 2014?
Provide a succinct answer. 1.04. What is the ratio of the Value added (% of GDP) of Grenada in 2013 to that in 2014?
Provide a succinct answer. 0.79. What is the ratio of the Value added (% of GDP) in Micronesia in 2013 to that in 2014?
Offer a terse response. 1.07. What is the ratio of the Value added (% of GDP) of Saudi Arabia in 2013 to that in 2014?
Give a very brief answer. 0.97. What is the difference between the highest and the second highest Value added (% of GDP) of Comoros?
Keep it short and to the point. 0.34. What is the difference between the highest and the second highest Value added (% of GDP) of Grenada?
Offer a very short reply. 1.47. What is the difference between the highest and the second highest Value added (% of GDP) in Micronesia?
Your answer should be compact. 1.77. What is the difference between the highest and the second highest Value added (% of GDP) in Saudi Arabia?
Provide a short and direct response. 0.47. What is the difference between the highest and the lowest Value added (% of GDP) of Comoros?
Your answer should be very brief. 7.79. What is the difference between the highest and the lowest Value added (% of GDP) in Grenada?
Your answer should be compact. 2.73. What is the difference between the highest and the lowest Value added (% of GDP) in Micronesia?
Offer a terse response. 4.05. What is the difference between the highest and the lowest Value added (% of GDP) in Saudi Arabia?
Your answer should be compact. 1.04. 